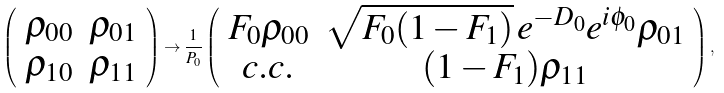<formula> <loc_0><loc_0><loc_500><loc_500>\left ( \begin{array} { c c } \rho _ { 0 0 } & \rho _ { 0 1 } \\ \rho _ { 1 0 } & \rho _ { 1 1 } \end{array} \right ) \rightarrow \frac { 1 } { P _ { 0 } } \left ( \begin{array} { c c } F _ { 0 } \rho _ { 0 0 } & \sqrt { F _ { 0 } ( 1 - F _ { 1 } ) } \, e ^ { - D _ { 0 } } e ^ { i \phi _ { 0 } } \rho _ { 0 1 } \\ c . c . & ( 1 - F _ { 1 } ) \rho _ { 1 1 } \end{array} \right ) ,</formula> 